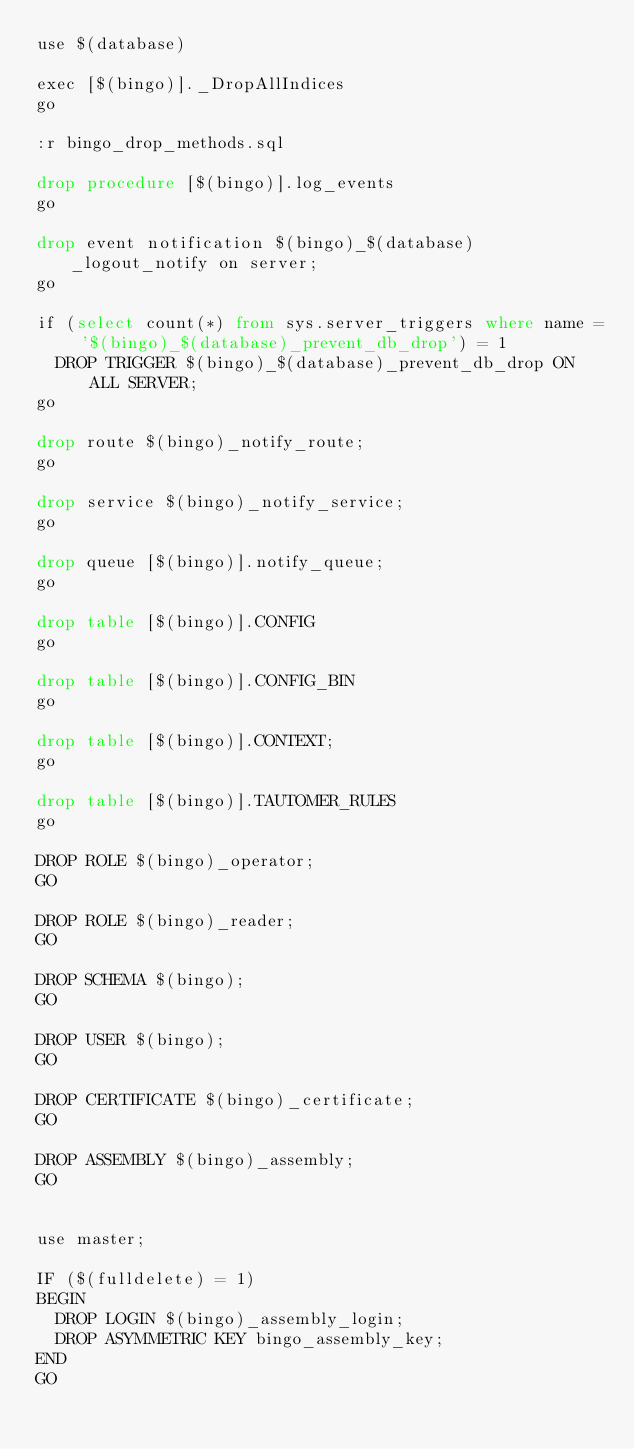Convert code to text. <code><loc_0><loc_0><loc_500><loc_500><_SQL_>use $(database)

exec [$(bingo)]._DropAllIndices
go

:r bingo_drop_methods.sql

drop procedure [$(bingo)].log_events
go

drop event notification $(bingo)_$(database)_logout_notify on server;
go

if (select count(*) from sys.server_triggers where name = '$(bingo)_$(database)_prevent_db_drop') = 1
	DROP TRIGGER $(bingo)_$(database)_prevent_db_drop ON ALL SERVER;
go

drop route $(bingo)_notify_route;
go

drop service $(bingo)_notify_service;
go

drop queue [$(bingo)].notify_queue;
go
                     
drop table [$(bingo)].CONFIG
go

drop table [$(bingo)].CONFIG_BIN
go

drop table [$(bingo)].CONTEXT;
go

drop table [$(bingo)].TAUTOMER_RULES
go

DROP ROLE $(bingo)_operator;
GO

DROP ROLE $(bingo)_reader;
GO

DROP SCHEMA $(bingo);
GO

DROP USER $(bingo);
GO

DROP CERTIFICATE $(bingo)_certificate;
GO

DROP ASSEMBLY $(bingo)_assembly;
GO


use master;

IF ($(fulldelete) = 1)
BEGIN
	DROP LOGIN $(bingo)_assembly_login;
	DROP ASYMMETRIC KEY bingo_assembly_key;
END
GO
</code> 